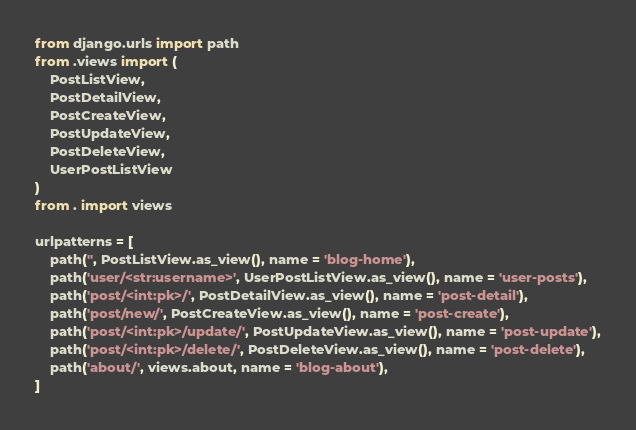Convert code to text. <code><loc_0><loc_0><loc_500><loc_500><_Python_>from django.urls import path
from .views import (
    PostListView,
    PostDetailView,
    PostCreateView,
    PostUpdateView,
    PostDeleteView,
    UserPostListView
)
from . import views

urlpatterns = [
    path('', PostListView.as_view(), name = 'blog-home'),
    path('user/<str:username>', UserPostListView.as_view(), name = 'user-posts'),
    path('post/<int:pk>/', PostDetailView.as_view(), name = 'post-detail'),
    path('post/new/', PostCreateView.as_view(), name = 'post-create'),
    path('post/<int:pk>/update/', PostUpdateView.as_view(), name = 'post-update'),
    path('post/<int:pk>/delete/', PostDeleteView.as_view(), name = 'post-delete'),
    path('about/', views.about, name = 'blog-about'),
]
</code> 